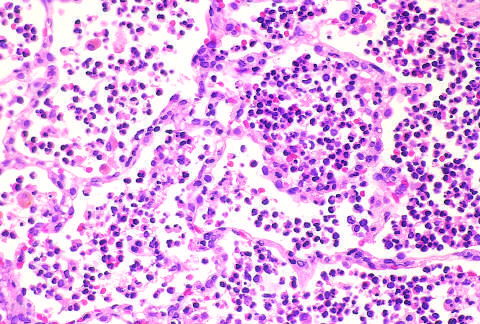do the congested septal capillaries and extensive neutrophil exudation into alveoli correspond to early red hepatization?
Answer the question using a single word or phrase. Yes 